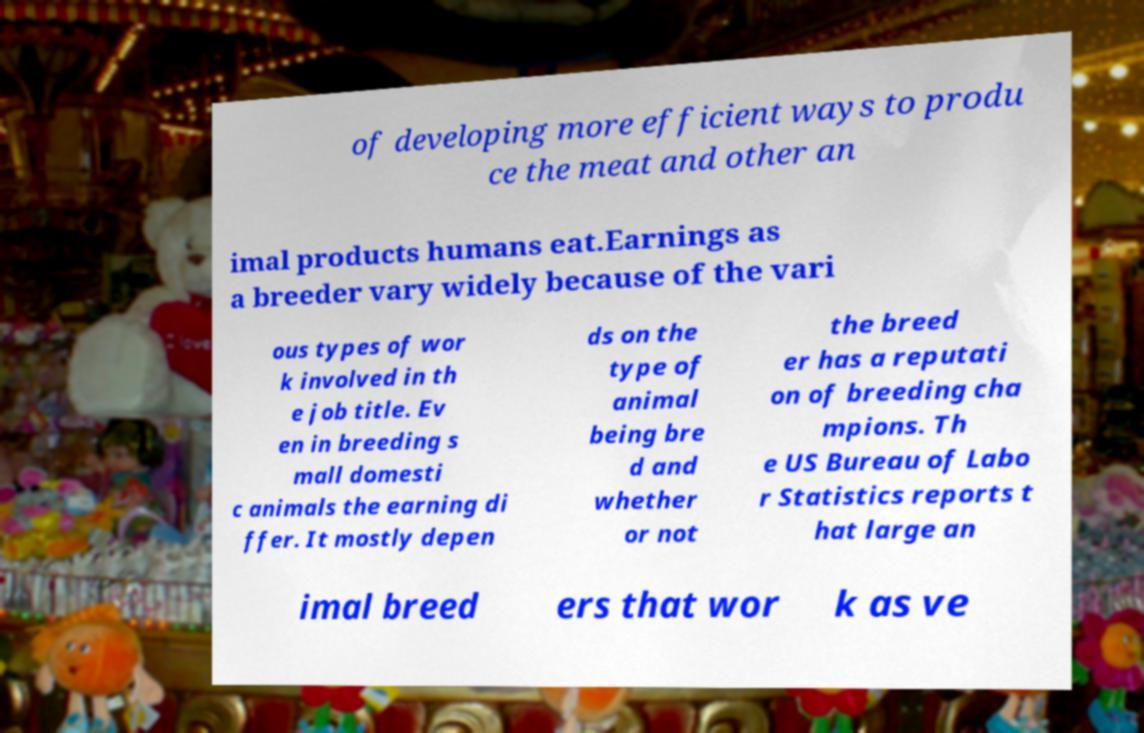Could you assist in decoding the text presented in this image and type it out clearly? of developing more efficient ways to produ ce the meat and other an imal products humans eat.Earnings as a breeder vary widely because of the vari ous types of wor k involved in th e job title. Ev en in breeding s mall domesti c animals the earning di ffer. It mostly depen ds on the type of animal being bre d and whether or not the breed er has a reputati on of breeding cha mpions. Th e US Bureau of Labo r Statistics reports t hat large an imal breed ers that wor k as ve 